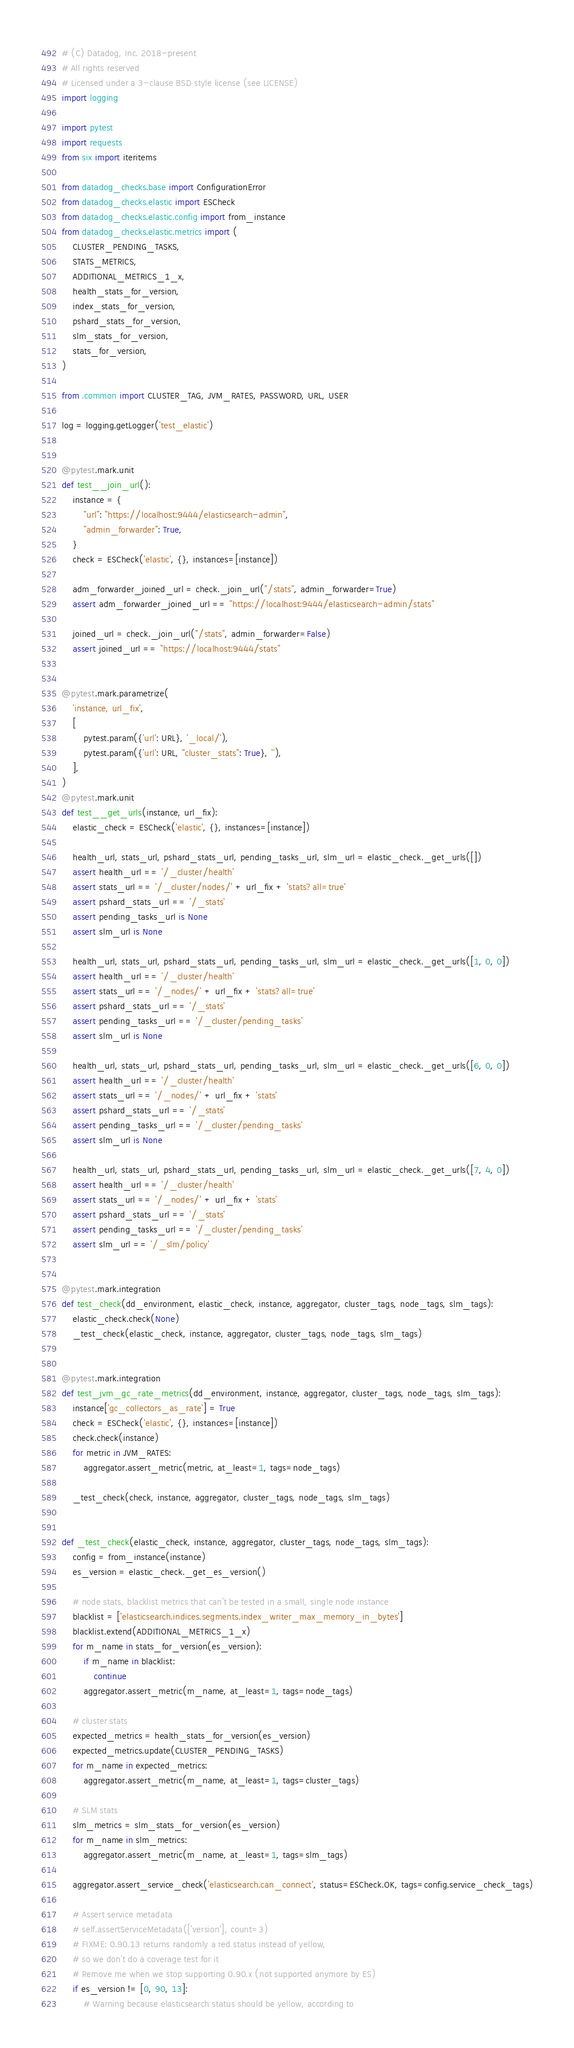<code> <loc_0><loc_0><loc_500><loc_500><_Python_># (C) Datadog, Inc. 2018-present
# All rights reserved
# Licensed under a 3-clause BSD style license (see LICENSE)
import logging

import pytest
import requests
from six import iteritems

from datadog_checks.base import ConfigurationError
from datadog_checks.elastic import ESCheck
from datadog_checks.elastic.config import from_instance
from datadog_checks.elastic.metrics import (
    CLUSTER_PENDING_TASKS,
    STATS_METRICS,
    ADDITIONAL_METRICS_1_x,
    health_stats_for_version,
    index_stats_for_version,
    pshard_stats_for_version,
    slm_stats_for_version,
    stats_for_version,
)

from .common import CLUSTER_TAG, JVM_RATES, PASSWORD, URL, USER

log = logging.getLogger('test_elastic')


@pytest.mark.unit
def test__join_url():
    instance = {
        "url": "https://localhost:9444/elasticsearch-admin",
        "admin_forwarder": True,
    }
    check = ESCheck('elastic', {}, instances=[instance])

    adm_forwarder_joined_url = check._join_url("/stats", admin_forwarder=True)
    assert adm_forwarder_joined_url == "https://localhost:9444/elasticsearch-admin/stats"

    joined_url = check._join_url("/stats", admin_forwarder=False)
    assert joined_url == "https://localhost:9444/stats"


@pytest.mark.parametrize(
    'instance, url_fix',
    [
        pytest.param({'url': URL}, '_local/'),
        pytest.param({'url': URL, "cluster_stats": True}, ''),
    ],
)
@pytest.mark.unit
def test__get_urls(instance, url_fix):
    elastic_check = ESCheck('elastic', {}, instances=[instance])

    health_url, stats_url, pshard_stats_url, pending_tasks_url, slm_url = elastic_check._get_urls([])
    assert health_url == '/_cluster/health'
    assert stats_url == '/_cluster/nodes/' + url_fix + 'stats?all=true'
    assert pshard_stats_url == '/_stats'
    assert pending_tasks_url is None
    assert slm_url is None

    health_url, stats_url, pshard_stats_url, pending_tasks_url, slm_url = elastic_check._get_urls([1, 0, 0])
    assert health_url == '/_cluster/health'
    assert stats_url == '/_nodes/' + url_fix + 'stats?all=true'
    assert pshard_stats_url == '/_stats'
    assert pending_tasks_url == '/_cluster/pending_tasks'
    assert slm_url is None

    health_url, stats_url, pshard_stats_url, pending_tasks_url, slm_url = elastic_check._get_urls([6, 0, 0])
    assert health_url == '/_cluster/health'
    assert stats_url == '/_nodes/' + url_fix + 'stats'
    assert pshard_stats_url == '/_stats'
    assert pending_tasks_url == '/_cluster/pending_tasks'
    assert slm_url is None

    health_url, stats_url, pshard_stats_url, pending_tasks_url, slm_url = elastic_check._get_urls([7, 4, 0])
    assert health_url == '/_cluster/health'
    assert stats_url == '/_nodes/' + url_fix + 'stats'
    assert pshard_stats_url == '/_stats'
    assert pending_tasks_url == '/_cluster/pending_tasks'
    assert slm_url == '/_slm/policy'


@pytest.mark.integration
def test_check(dd_environment, elastic_check, instance, aggregator, cluster_tags, node_tags, slm_tags):
    elastic_check.check(None)
    _test_check(elastic_check, instance, aggregator, cluster_tags, node_tags, slm_tags)


@pytest.mark.integration
def test_jvm_gc_rate_metrics(dd_environment, instance, aggregator, cluster_tags, node_tags, slm_tags):
    instance['gc_collectors_as_rate'] = True
    check = ESCheck('elastic', {}, instances=[instance])
    check.check(instance)
    for metric in JVM_RATES:
        aggregator.assert_metric(metric, at_least=1, tags=node_tags)

    _test_check(check, instance, aggregator, cluster_tags, node_tags, slm_tags)


def _test_check(elastic_check, instance, aggregator, cluster_tags, node_tags, slm_tags):
    config = from_instance(instance)
    es_version = elastic_check._get_es_version()

    # node stats, blacklist metrics that can't be tested in a small, single node instance
    blacklist = ['elasticsearch.indices.segments.index_writer_max_memory_in_bytes']
    blacklist.extend(ADDITIONAL_METRICS_1_x)
    for m_name in stats_for_version(es_version):
        if m_name in blacklist:
            continue
        aggregator.assert_metric(m_name, at_least=1, tags=node_tags)

    # cluster stats
    expected_metrics = health_stats_for_version(es_version)
    expected_metrics.update(CLUSTER_PENDING_TASKS)
    for m_name in expected_metrics:
        aggregator.assert_metric(m_name, at_least=1, tags=cluster_tags)

    # SLM stats
    slm_metrics = slm_stats_for_version(es_version)
    for m_name in slm_metrics:
        aggregator.assert_metric(m_name, at_least=1, tags=slm_tags)

    aggregator.assert_service_check('elasticsearch.can_connect', status=ESCheck.OK, tags=config.service_check_tags)

    # Assert service metadata
    # self.assertServiceMetadata(['version'], count=3)
    # FIXME: 0.90.13 returns randomly a red status instead of yellow,
    # so we don't do a coverage test for it
    # Remove me when we stop supporting 0.90.x (not supported anymore by ES)
    if es_version != [0, 90, 13]:
        # Warning because elasticsearch status should be yellow, according to</code> 